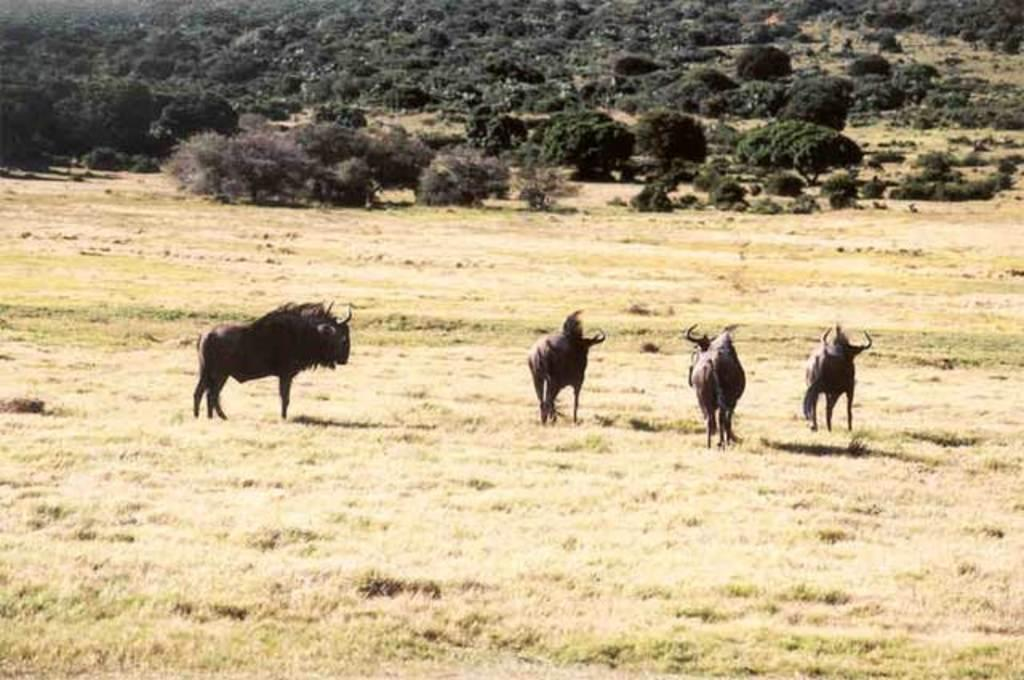What type of living organisms can be seen in the image? There are animals in the image. What type of vegetation is visible in the image? There is grass, trees, and plants visible in the image. What type of ring can be seen on the animal's nose in the image? There are no rings visible on any animals in the image, and no animals have their noses shown. 